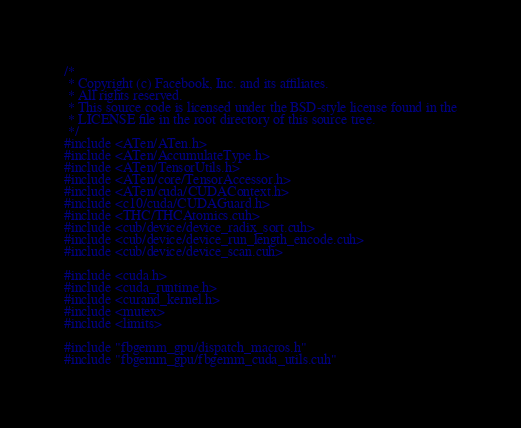<code> <loc_0><loc_0><loc_500><loc_500><_Cuda_>/*
 * Copyright (c) Facebook, Inc. and its affiliates.
 * All rights reserved.
 * This source code is licensed under the BSD-style license found in the
 * LICENSE file in the root directory of this source tree.
 */
#include <ATen/ATen.h>
#include <ATen/AccumulateType.h>
#include <ATen/TensorUtils.h>
#include <ATen/core/TensorAccessor.h>
#include <ATen/cuda/CUDAContext.h>
#include <c10/cuda/CUDAGuard.h>
#include <THC/THCAtomics.cuh>
#include <cub/device/device_radix_sort.cuh>
#include <cub/device/device_run_length_encode.cuh>
#include <cub/device/device_scan.cuh>

#include <cuda.h>
#include <cuda_runtime.h>
#include <curand_kernel.h>
#include <mutex>
#include <limits>

#include "fbgemm_gpu/dispatch_macros.h"
#include "fbgemm_gpu/fbgemm_cuda_utils.cuh"
</code> 